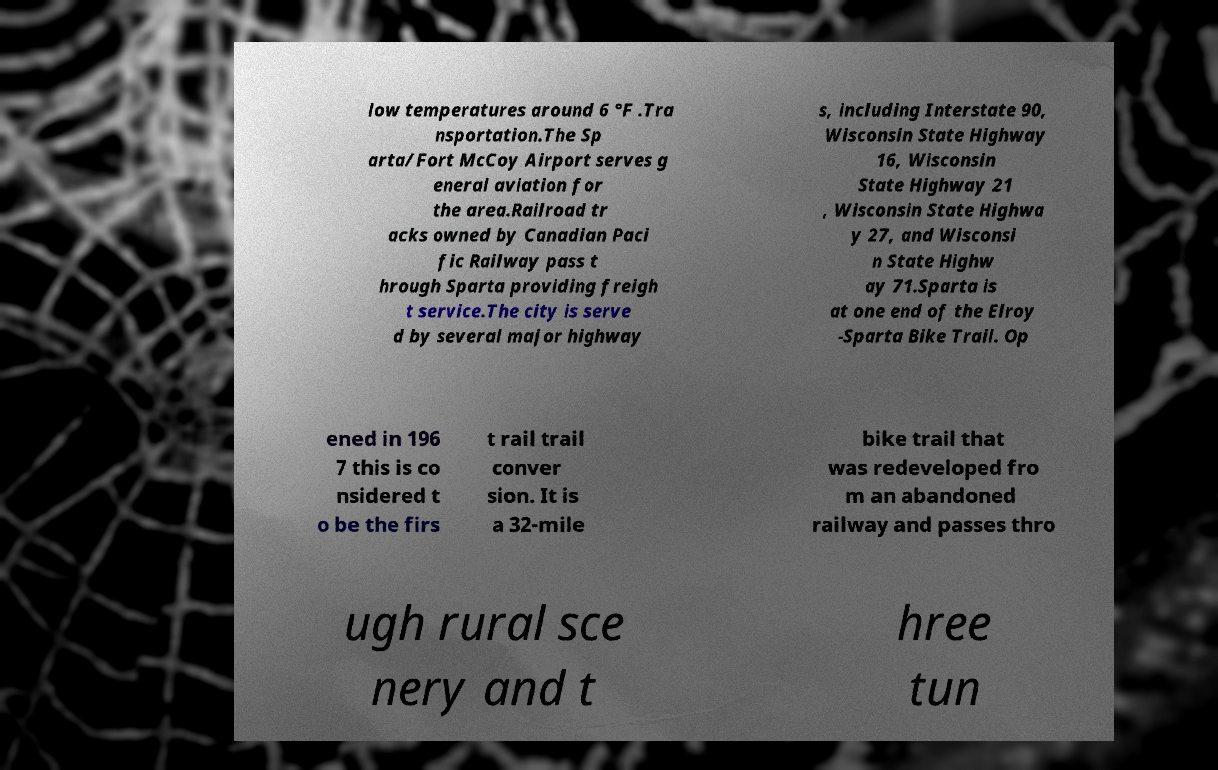Can you read and provide the text displayed in the image?This photo seems to have some interesting text. Can you extract and type it out for me? low temperatures around 6 °F .Tra nsportation.The Sp arta/Fort McCoy Airport serves g eneral aviation for the area.Railroad tr acks owned by Canadian Paci fic Railway pass t hrough Sparta providing freigh t service.The city is serve d by several major highway s, including Interstate 90, Wisconsin State Highway 16, Wisconsin State Highway 21 , Wisconsin State Highwa y 27, and Wisconsi n State Highw ay 71.Sparta is at one end of the Elroy -Sparta Bike Trail. Op ened in 196 7 this is co nsidered t o be the firs t rail trail conver sion. It is a 32-mile bike trail that was redeveloped fro m an abandoned railway and passes thro ugh rural sce nery and t hree tun 